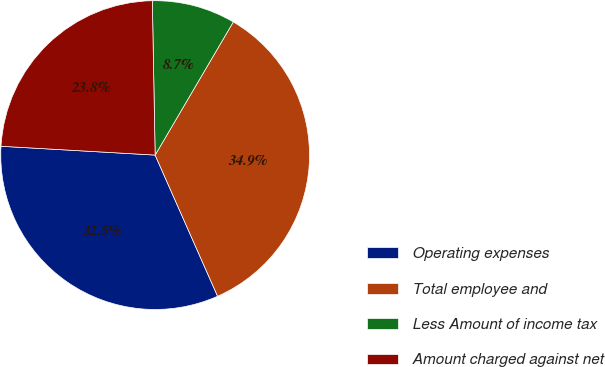<chart> <loc_0><loc_0><loc_500><loc_500><pie_chart><fcel>Operating expenses<fcel>Total employee and<fcel>Less Amount of income tax<fcel>Amount charged against net<nl><fcel>32.54%<fcel>34.92%<fcel>8.74%<fcel>23.8%<nl></chart> 